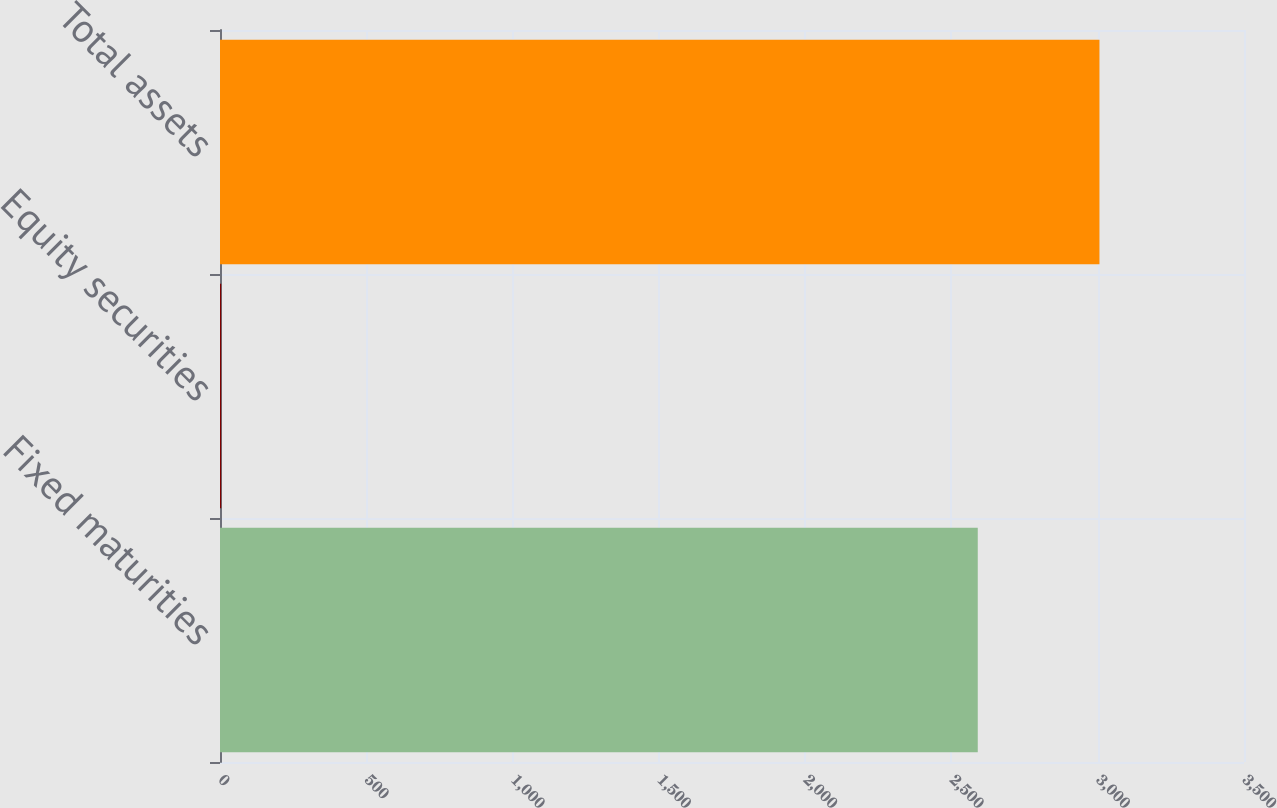<chart> <loc_0><loc_0><loc_500><loc_500><bar_chart><fcel>Fixed maturities<fcel>Equity securities<fcel>Total assets<nl><fcel>2590<fcel>4<fcel>3006<nl></chart> 